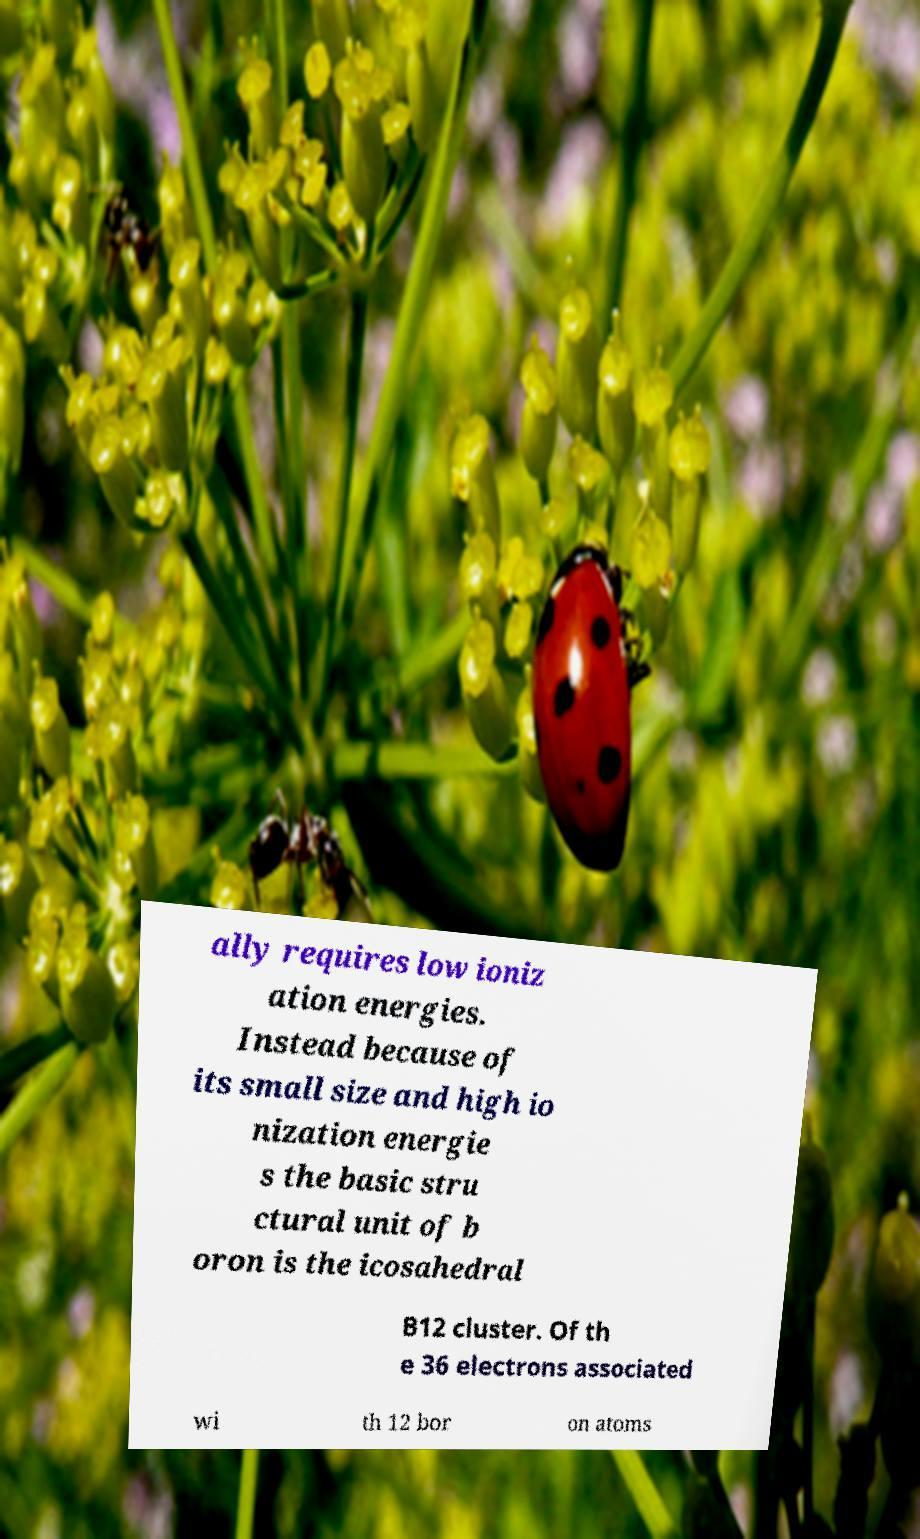What messages or text are displayed in this image? I need them in a readable, typed format. ally requires low ioniz ation energies. Instead because of its small size and high io nization energie s the basic stru ctural unit of b oron is the icosahedral B12 cluster. Of th e 36 electrons associated wi th 12 bor on atoms 